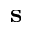Convert formula to latex. <formula><loc_0><loc_0><loc_500><loc_500>s</formula> 